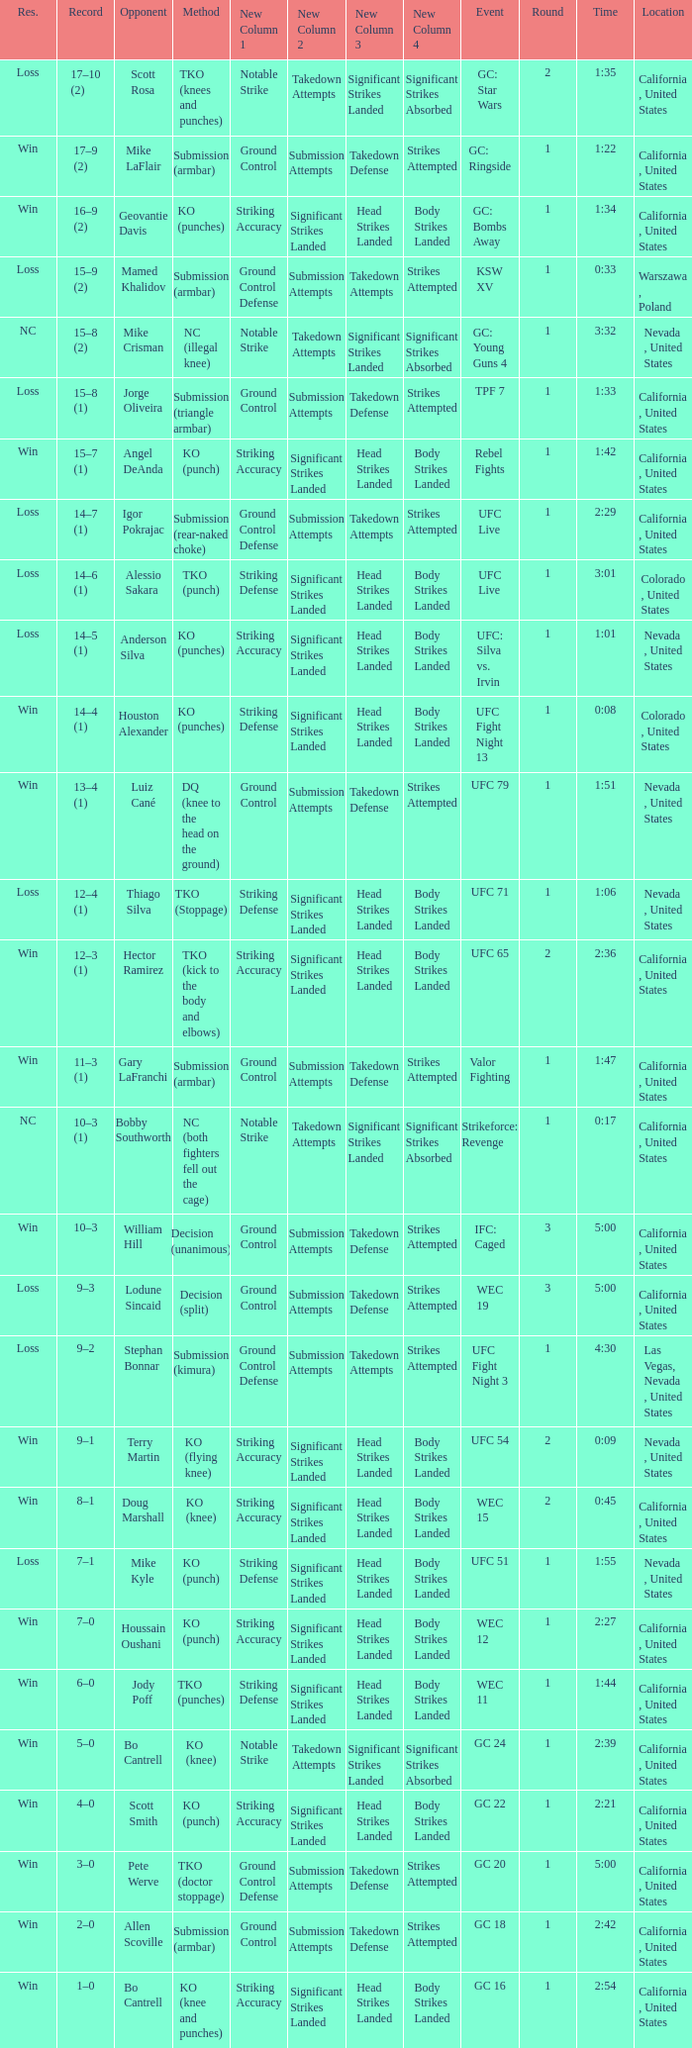What was the method when the time was 1:01? KO (punches). 